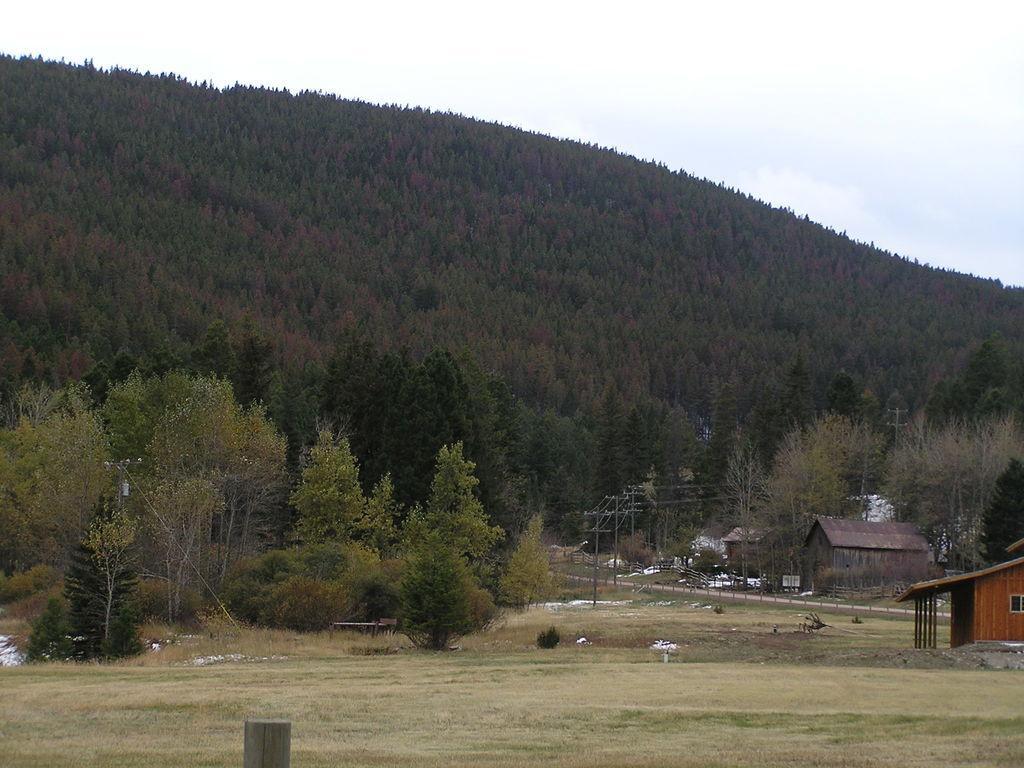In one or two sentences, can you explain what this image depicts? In the foreground of the image we can see the grass. In the middle of the image we can see the road, houses, trees and current polls. On the top of the image we can see the trees and the sky. 